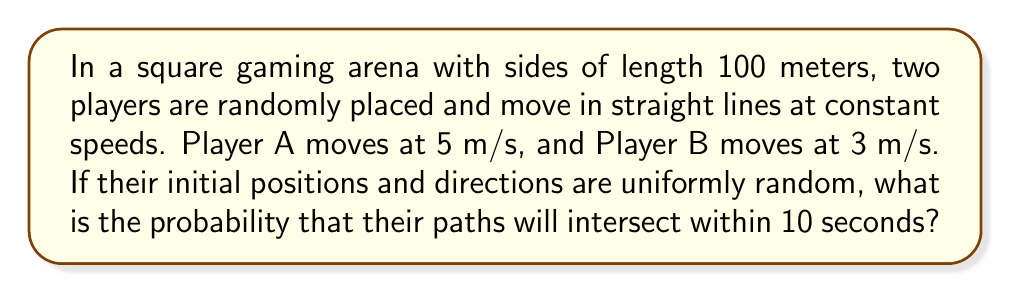Solve this math problem. Let's approach this step-by-step:

1) First, we need to calculate the area swept by each player in 10 seconds:
   - Player A: $5 \text{ m/s} \times 10 \text{ s} = 50 \text{ m}$ (length)
   - Player B: $3 \text{ m/s} \times 10 \text{ s} = 30 \text{ m}$ (length)

2) The area swept by each player forms a rectangle:
   - Player A: $50 \text{ m} \times 100 \text{ m} = 5000 \text{ m}^2$
   - Player B: $30 \text{ m} \times 100 \text{ m} = 3000 \text{ m}^2$

3) The probability of intersection is the probability that Player B's path crosses the area swept by Player A. This is equivalent to the probability that the center of Player B's path falls within the expanded area of Player A's path.

4) The expanded area is a cross shape:
   
   [asy]
   size(200);
   draw((0,0)--(100,0)--(100,100)--(0,100)--cycle);
   fill((25,0)--(75,0)--(75,100)--(25,100)--cycle,gray(0.7));
   fill((0,35)--(100,35)--(100,65)--(0,65)--cycle,gray(0.7));
   label("100m",(-5,50),W);
   label("100m",(50,-5),S);
   label("50m",(50,102),N);
   label("30m",(102,50),E);
   [/asy]

5) The area of this cross shape is:
   $A_{\text{cross}} = 100 \times 50 + 100 \times 30 - 50 \times 30 = 8500 \text{ m}^2$

6) The probability is the ratio of this area to the total area:
   $P(\text{intersection}) = \frac{A_{\text{cross}}}{A_{\text{total}}} = \frac{8500}{100 \times 100} = 0.85$

Therefore, the probability of the paths intersecting within 10 seconds is 0.85 or 85%.
Answer: 0.85 